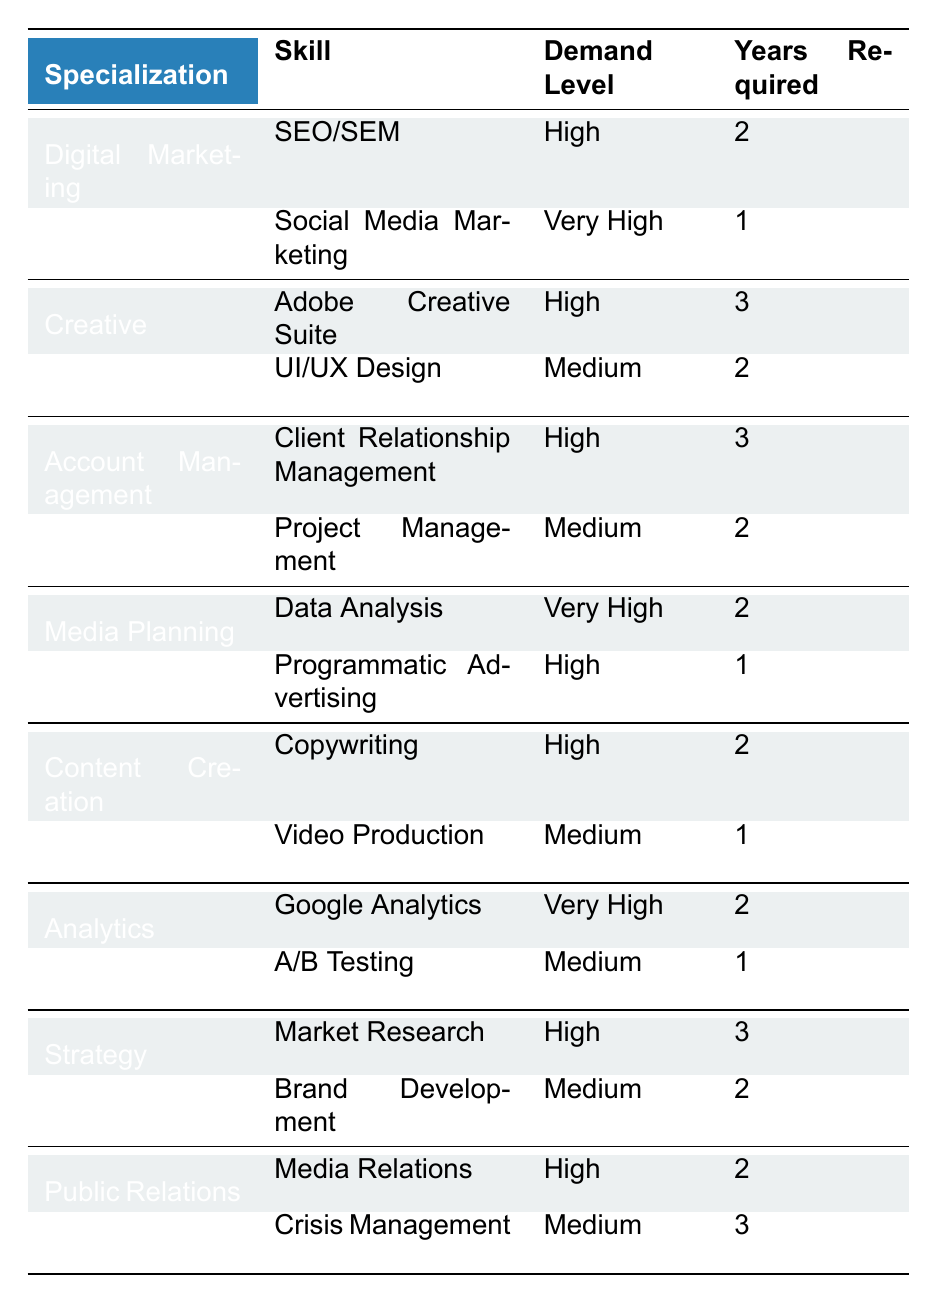What is the most in-demand skill in Digital Marketing? The table indicates "Social Media Marketing" as having a "Very High" demand level within Digital Marketing.
Answer: Social Media Marketing How many years of experience are required for a role in Creative specializing in Adobe Creative Suite? The table states that "Adobe Creative Suite" under Creative requires 3 years of experience.
Answer: 3 years Which specialization has the highest demand level for skills? By reviewing the table, Digital Marketing and Media Planning showcase skills with "Very High" demand levels, which is the highest category.
Answer: Digital Marketing and Media Planning Is Project Management considered a high-demand skill? The table categorizes "Project Management" under Account Management as having a "Medium" demand level, therefore it is not considered high demand.
Answer: No How many skills in the Public Relations specialization require 3 years of experience? The table shows one skill, "Crisis Management," requiring 3 years of experience in Public Relations.
Answer: 1 Which specialization has skills with both high and medium demand levels? The table lists Account Management as having "Client Relationship Management" with high demand and "Project Management" with medium demand.
Answer: Account Management What percentage of the skills listed in the table have a "Very High" demand level? There are 16 skills total, and 4 are classified as "Very High", so (4/16)*100 = 25%.
Answer: 25% For how many specializations is the skill "Data Analysis" listed, and how many years of experience does it require? "Data Analysis" is listed under Media Planning, requiring 2 years of experience. Hence, there is 1 specialization.
Answer: 1 specialization, 2 years Which skill requires the least amount of experience in the table? "Social Media Marketing" requires only 1 year of experience, the lowest among all skills listed.
Answer: 1 year If you want to work in Strategy, what is the most demanding skill you need? Among the skills listed under Strategy, "Market Research" is classified as having a "High" demand level.
Answer: Market Research 